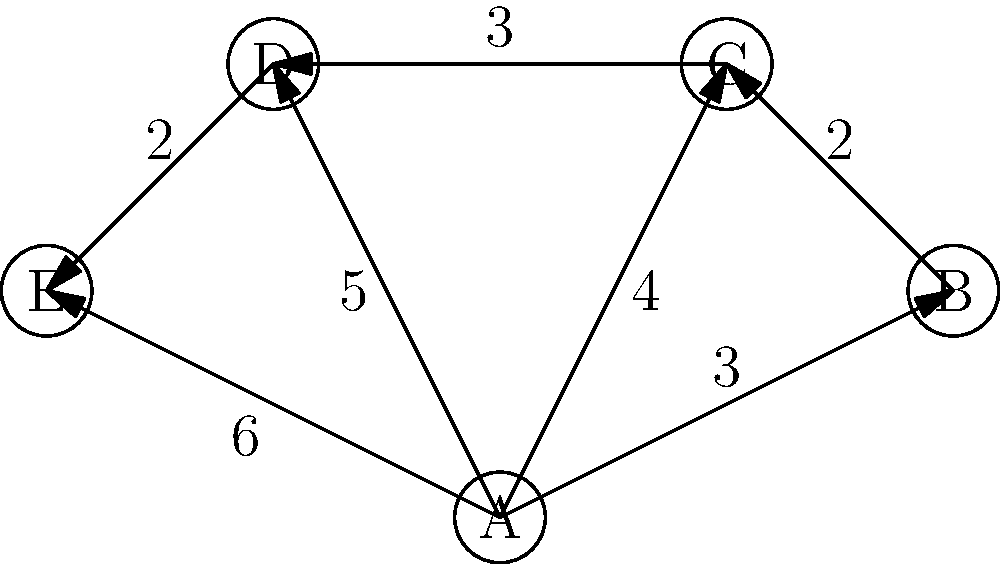A therapy dog named Max is stationed at point A in a hospital. Max needs to visit patients at points B, C, D, and E in the most efficient order. The numbers on the edges represent the time (in minutes) it takes Max to travel between points. What is the shortest total time for Max to visit all patients and return to point A? To find the shortest path for Max to visit all patients and return to point A, we need to consider all possible routes and calculate their total times. Here's how we can approach this:

1. List all possible routes:
   ABCDEA, ABCEDA, ABDCEA, ABDECA, ACBDEA, ACDEBA, ADCBEA, ADEBCA, AEBCDA, AEDCBA

2. Calculate the time for each route:
   ABCDEA: 3 + 2 + 3 + 2 + 6 = 16
   ABCEDA: 3 + 2 + 3 + 2 + 5 = 15
   ABDCEA: 3 + 5 + 3 + 2 + 3 = 16
   ABDECA: 3 + 5 + 2 + 2 + 3 = 15
   ACBDEA: 4 + 2 + 5 + 2 + 6 = 19
   ACDEBA: 4 + 3 + 2 + 2 + 3 = 14
   ADCBEA: 5 + 3 + 2 + 3 + 3 = 16
   ADEBCA: 5 + 2 + 2 + 3 + 3 = 15
   AEBCDA: 6 + 3 + 2 + 3 + 5 = 19
   AEDCBA: 6 + 2 + 3 + 2 + 3 = 16

3. Identify the shortest route:
   The route ACDEBA has the shortest total time of 14 minutes.

Therefore, the most efficient path for Max is to go from A to C, then to D, E, B, and finally back to A, taking a total of 14 minutes.
Answer: 14 minutes 